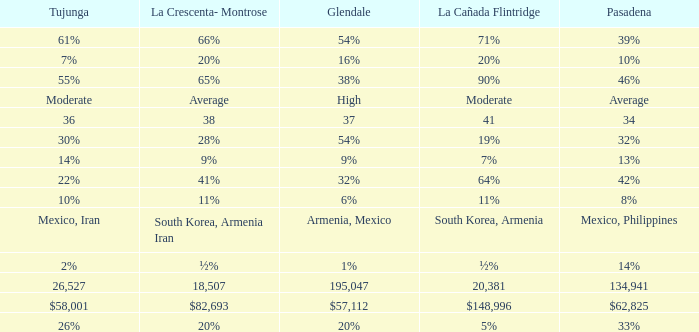What is the percentage of Tukunga when La Crescenta-Montrose is 28%? 30%. 